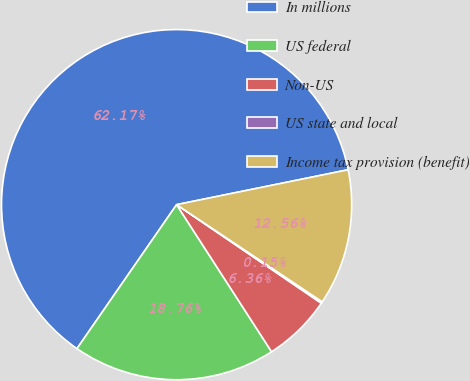Convert chart. <chart><loc_0><loc_0><loc_500><loc_500><pie_chart><fcel>In millions<fcel>US federal<fcel>Non-US<fcel>US state and local<fcel>Income tax provision (benefit)<nl><fcel>62.17%<fcel>18.76%<fcel>6.36%<fcel>0.15%<fcel>12.56%<nl></chart> 